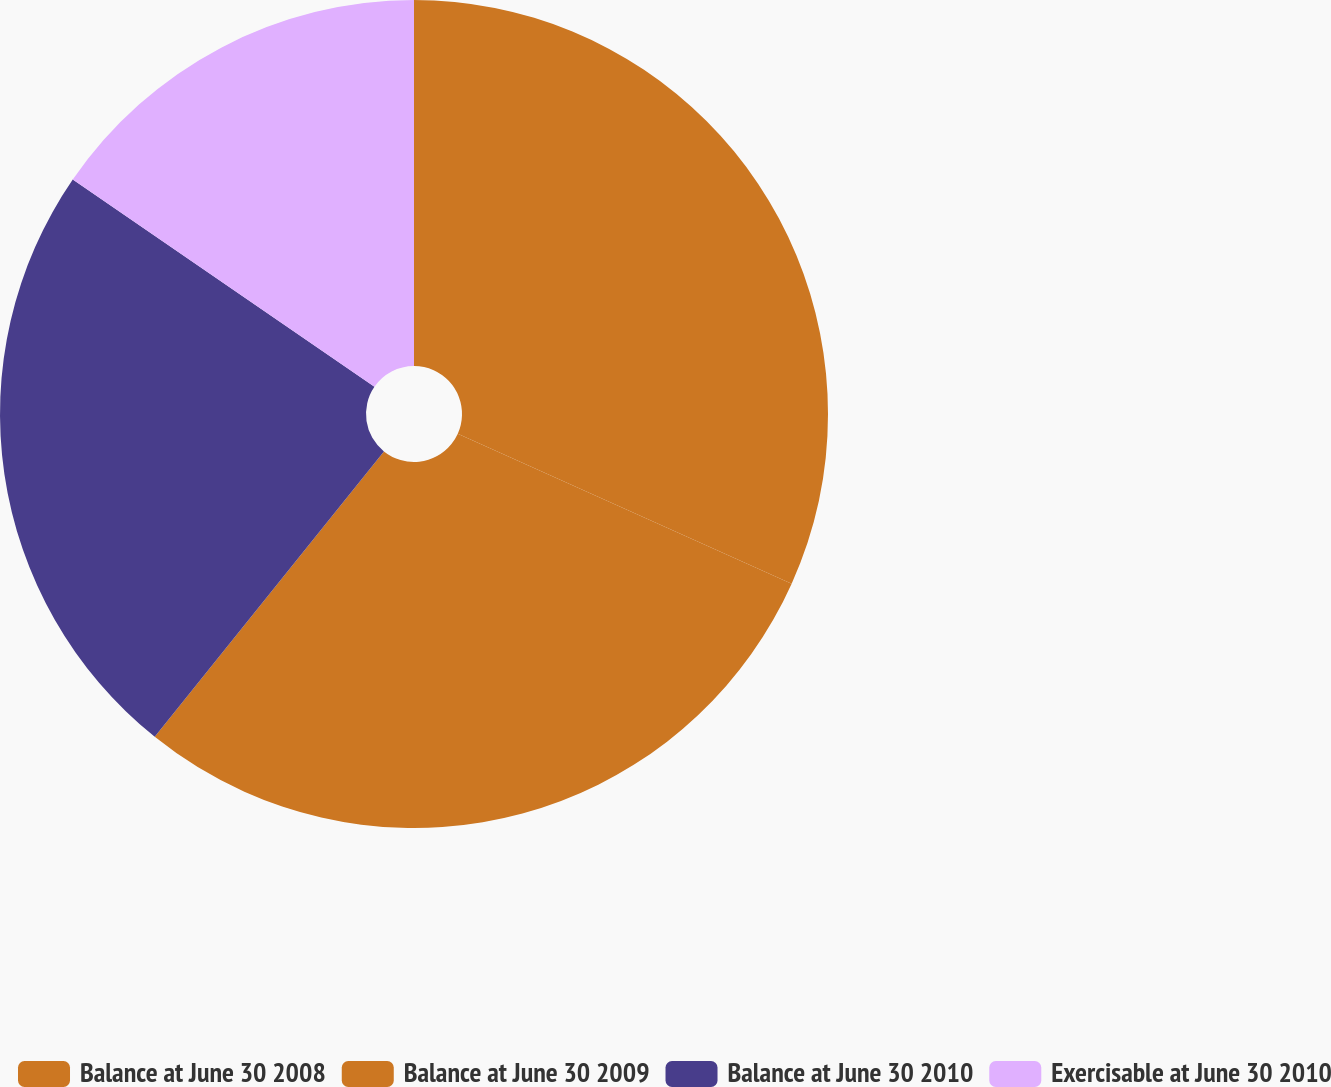<chart> <loc_0><loc_0><loc_500><loc_500><pie_chart><fcel>Balance at June 30 2008<fcel>Balance at June 30 2009<fcel>Balance at June 30 2010<fcel>Exercisable at June 30 2010<nl><fcel>31.72%<fcel>29.05%<fcel>23.81%<fcel>15.42%<nl></chart> 